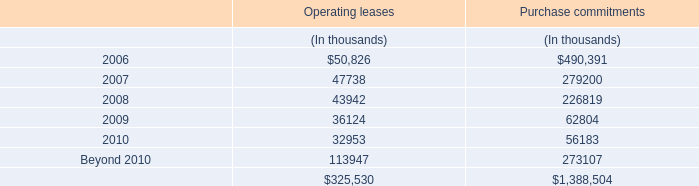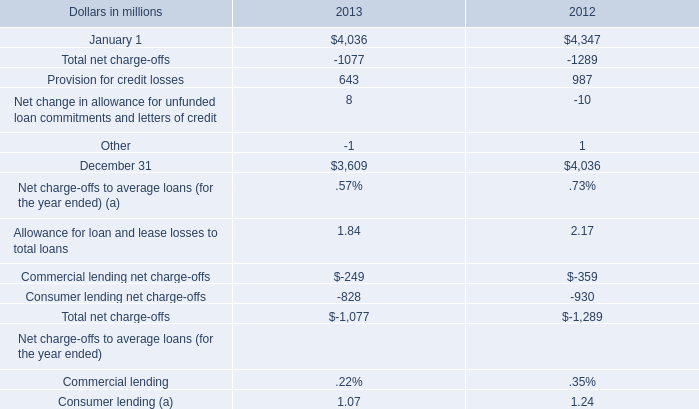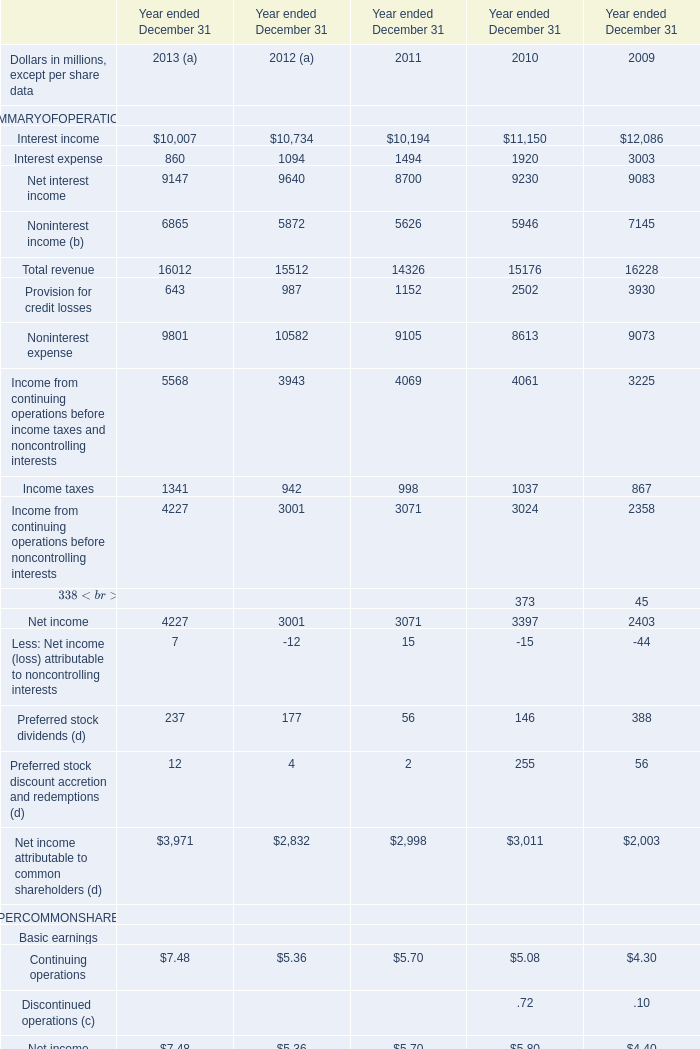What is the sum of Interest expense of Year ended December 31 2009, January 1 of 2013, and Net income of Year ended December 31 2011 ? 
Computations: ((3003.0 + 4036.0) + 3071.0)
Answer: 10110.0. 